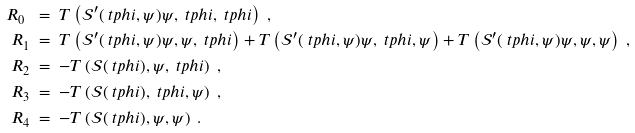<formula> <loc_0><loc_0><loc_500><loc_500>R _ { 0 } \ & = \ T \left ( \mathcal { S } ^ { \prime } ( \ t p h i , \psi ) \psi , \ t p h i , \ t p h i \right ) \ , \\ R _ { 1 } \ & = \ T \left ( \mathcal { S } ^ { \prime } ( \ t p h i , \psi ) \psi , \psi , \ t p h i \right ) + T \left ( \mathcal { S } ^ { \prime } ( \ t p h i , \psi ) \psi , \ t p h i , \psi \right ) + T \left ( \mathcal { S } ^ { \prime } ( \ t p h i , \psi ) \psi , \psi , \psi \right ) \ , \\ R _ { 2 } \ & = \ - T \left ( \mathcal { S } ( \ t p h i ) , \psi , \ t p h i \right ) \ , \\ R _ { 3 } \ & = \ - T \left ( \mathcal { S } ( \ t p h i ) , \ t p h i , \psi \right ) \ , \\ R _ { 4 } \ & = \ - T \left ( \mathcal { S } ( \ t p h i ) , \psi , \psi \right ) \ .</formula> 